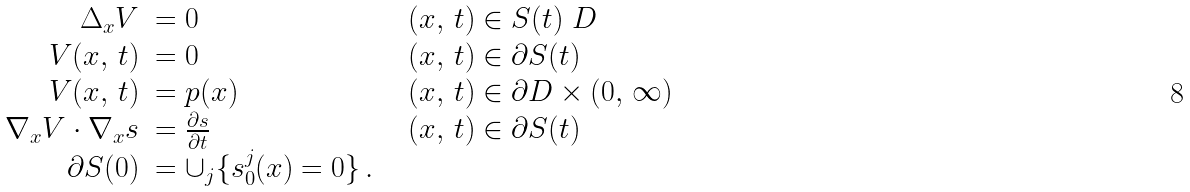<formula> <loc_0><loc_0><loc_500><loc_500>\begin{array} { r l l } \Delta _ { x } V & = 0 \ \ & ( x , \, t ) \in S ( t ) \ D \\ V ( x , \, t ) & = 0 \ \ & ( x , \, t ) \in \partial S ( t ) \\ V ( x , \, t ) & = p ( x ) \ \ & ( x , \, t ) \in \partial D \times ( 0 , \, \infty ) \\ \nabla _ { x } V \cdot \nabla _ { x } s & = \frac { \partial s } { \partial t } \ \ & ( x , \, t ) \in \partial S ( t ) \\ \partial S ( 0 ) & = \cup _ { j } \{ s ^ { j } _ { 0 } ( x ) = 0 \} \, . \ \ & \ \end{array}</formula> 